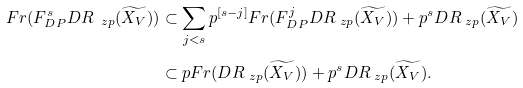Convert formula to latex. <formula><loc_0><loc_0><loc_500><loc_500>F r ( F _ { D P } ^ { s } D R _ { \ z p } ( \widetilde { X _ { V } } ) ) & \subset \sum _ { j < s } p ^ { [ s - j ] } F r ( F _ { D P } ^ { j } D R _ { \ z p } ( \widetilde { X _ { V } } ) ) + p ^ { s } D R _ { \ z p } ( \widetilde { X _ { V } } ) \\ & \subset p F r ( D R _ { \ z p } ( \widetilde { X _ { V } } ) ) + p ^ { s } D R _ { \ z p } ( \widetilde { X _ { V } } ) . \\</formula> 